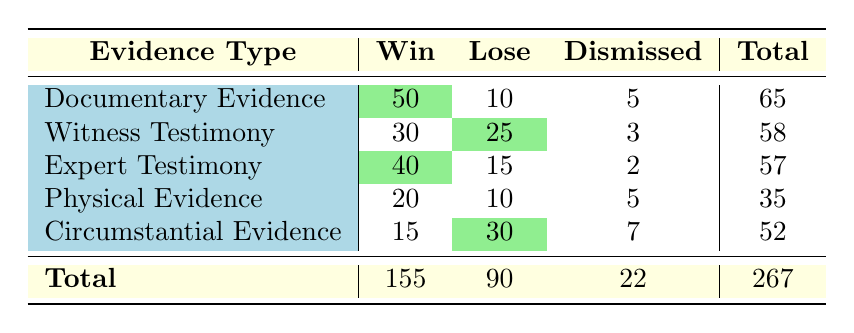What is the total number of cases with Documentary Evidence? There are three outcomes for Documentary Evidence: Win (50), Lose (10), and Dismissed (5). Summing these values gives 50 + 10 + 5 = 65 cases.
Answer: 65 How many cases resulted in a Win across all types of evidence? The Wins are: Documentary Evidence (50), Witness Testimony (30), Expert Testimony (40), Physical Evidence (20), and Circumstantial Evidence (15). Summing these gives 50 + 30 + 40 + 20 + 15 = 155 Wins.
Answer: 155 Did any evidence type have more Dismissed cases than Wins? Looking at the Dismissed cases: Documentary (5), Witness (3), Expert (2), Physical (5), and Circumstantial (7). All Wins are: Documentary (50), Witness (30), Expert (40), Physical (20), Circumstantial (15). None of the evidence types have more Dismissed cases than Wins since the highest Dismissed case count is 7, which is less than the least Win case count of 15.
Answer: No Which evidence type had the highest number of Losing cases? Reviewing the Losing cases: Documentary (10), Witness (25), Expert (15), Physical (10), Circumstantial (30). The highest count is for Circumstantial Evidence with 30 Lose cases.
Answer: Circumstantial Evidence What is the average number of cases for each case outcome (Win, Lose, Dismissed)? First, we sum the cases for each outcome: Wins (155), Loses (90), Dismissed (22). There are 5 evidence types, so, the averages are calculated as follows: Win average = 155/5 = 31, Lose average = 90/5 = 18, Dismissed average = 22/5 = 4.4.
Answer: Win: 31, Lose: 18, Dismissed: 4.4 